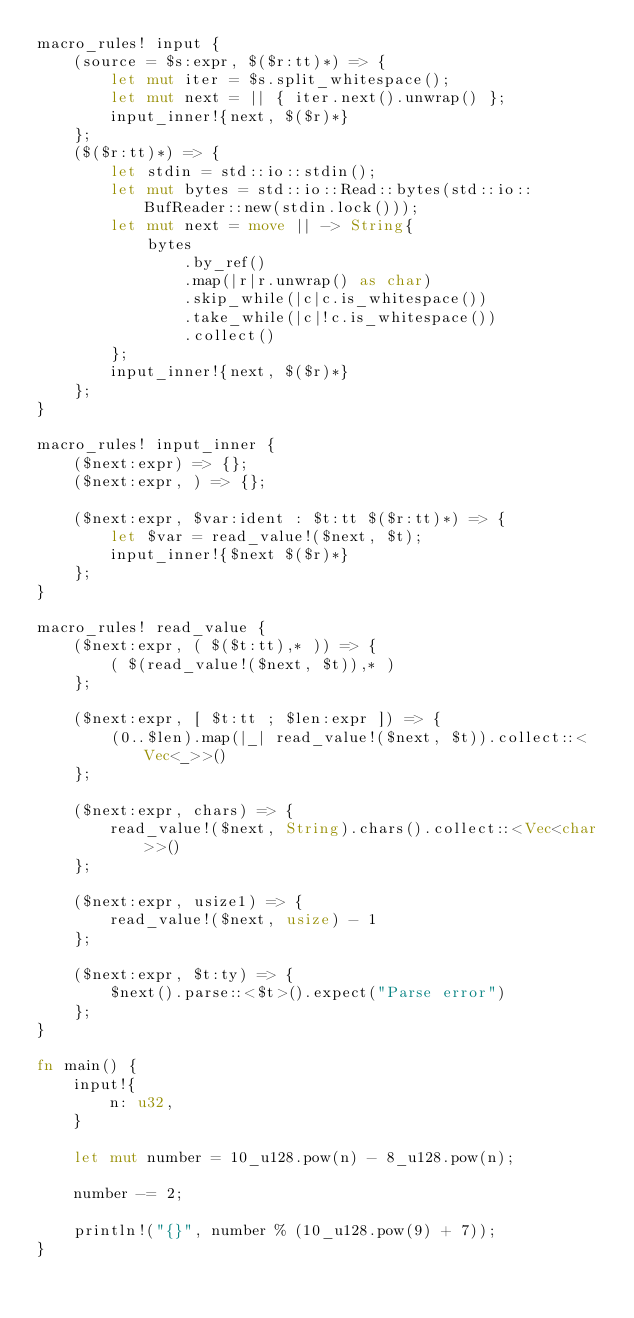<code> <loc_0><loc_0><loc_500><loc_500><_Rust_>macro_rules! input {
    (source = $s:expr, $($r:tt)*) => {
        let mut iter = $s.split_whitespace();
        let mut next = || { iter.next().unwrap() };
        input_inner!{next, $($r)*}
    };
    ($($r:tt)*) => {
        let stdin = std::io::stdin();
        let mut bytes = std::io::Read::bytes(std::io::BufReader::new(stdin.lock()));
        let mut next = move || -> String{
            bytes
                .by_ref()
                .map(|r|r.unwrap() as char)
                .skip_while(|c|c.is_whitespace())
                .take_while(|c|!c.is_whitespace())
                .collect()
        };
        input_inner!{next, $($r)*}
    };
}

macro_rules! input_inner {
    ($next:expr) => {};
    ($next:expr, ) => {};

    ($next:expr, $var:ident : $t:tt $($r:tt)*) => {
        let $var = read_value!($next, $t);
        input_inner!{$next $($r)*}
    };
}

macro_rules! read_value {
    ($next:expr, ( $($t:tt),* )) => {
        ( $(read_value!($next, $t)),* )
    };

    ($next:expr, [ $t:tt ; $len:expr ]) => {
        (0..$len).map(|_| read_value!($next, $t)).collect::<Vec<_>>()
    };

    ($next:expr, chars) => {
        read_value!($next, String).chars().collect::<Vec<char>>()
    };

    ($next:expr, usize1) => {
        read_value!($next, usize) - 1
    };

    ($next:expr, $t:ty) => {
        $next().parse::<$t>().expect("Parse error")
    };
}

fn main() {
    input!{
        n: u32,
    }

    let mut number = 10_u128.pow(n) - 8_u128.pow(n);

    number -= 2;

    println!("{}", number % (10_u128.pow(9) + 7));
}
</code> 